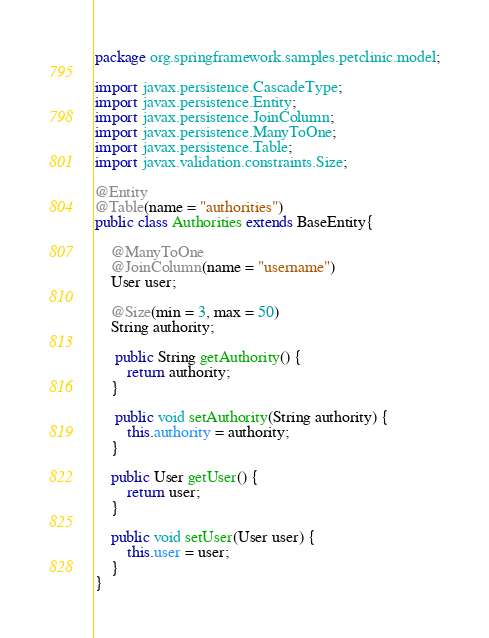<code> <loc_0><loc_0><loc_500><loc_500><_Java_>package org.springframework.samples.petclinic.model;

import javax.persistence.CascadeType;
import javax.persistence.Entity;
import javax.persistence.JoinColumn;
import javax.persistence.ManyToOne;
import javax.persistence.Table;
import javax.validation.constraints.Size;

@Entity
@Table(name = "authorities")
public class Authorities extends BaseEntity{
	
	@ManyToOne
	@JoinColumn(name = "username")
	User user;
	
	@Size(min = 3, max = 50)
	String authority;
	
	 public String getAuthority() {
		return authority;
	}
	 
	 public void setAuthority(String authority) {
		this.authority = authority;
	}
	 
	public User getUser() {
		return user;
	}
	
	public void setUser(User user) {
		this.user = user;
	}
}
</code> 